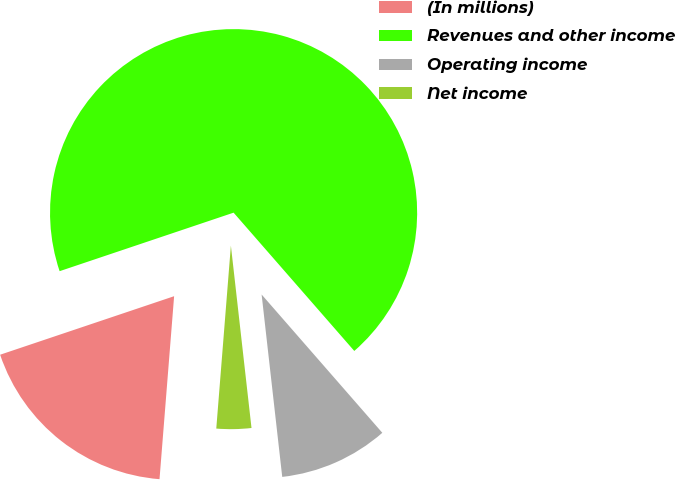<chart> <loc_0><loc_0><loc_500><loc_500><pie_chart><fcel>(In millions)<fcel>Revenues and other income<fcel>Operating income<fcel>Net income<nl><fcel>18.57%<fcel>68.75%<fcel>9.63%<fcel>3.06%<nl></chart> 